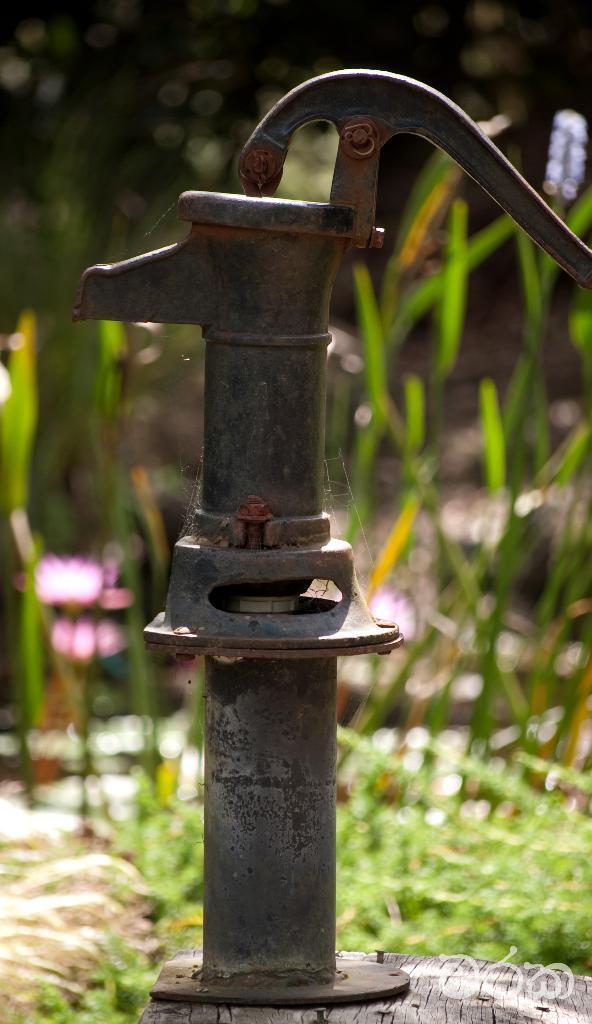Please provide a concise description of this image. In this picture I can see a hand pump in front and it is on the wooden surface. In the background I can see the planets and I see that it is blurred. 